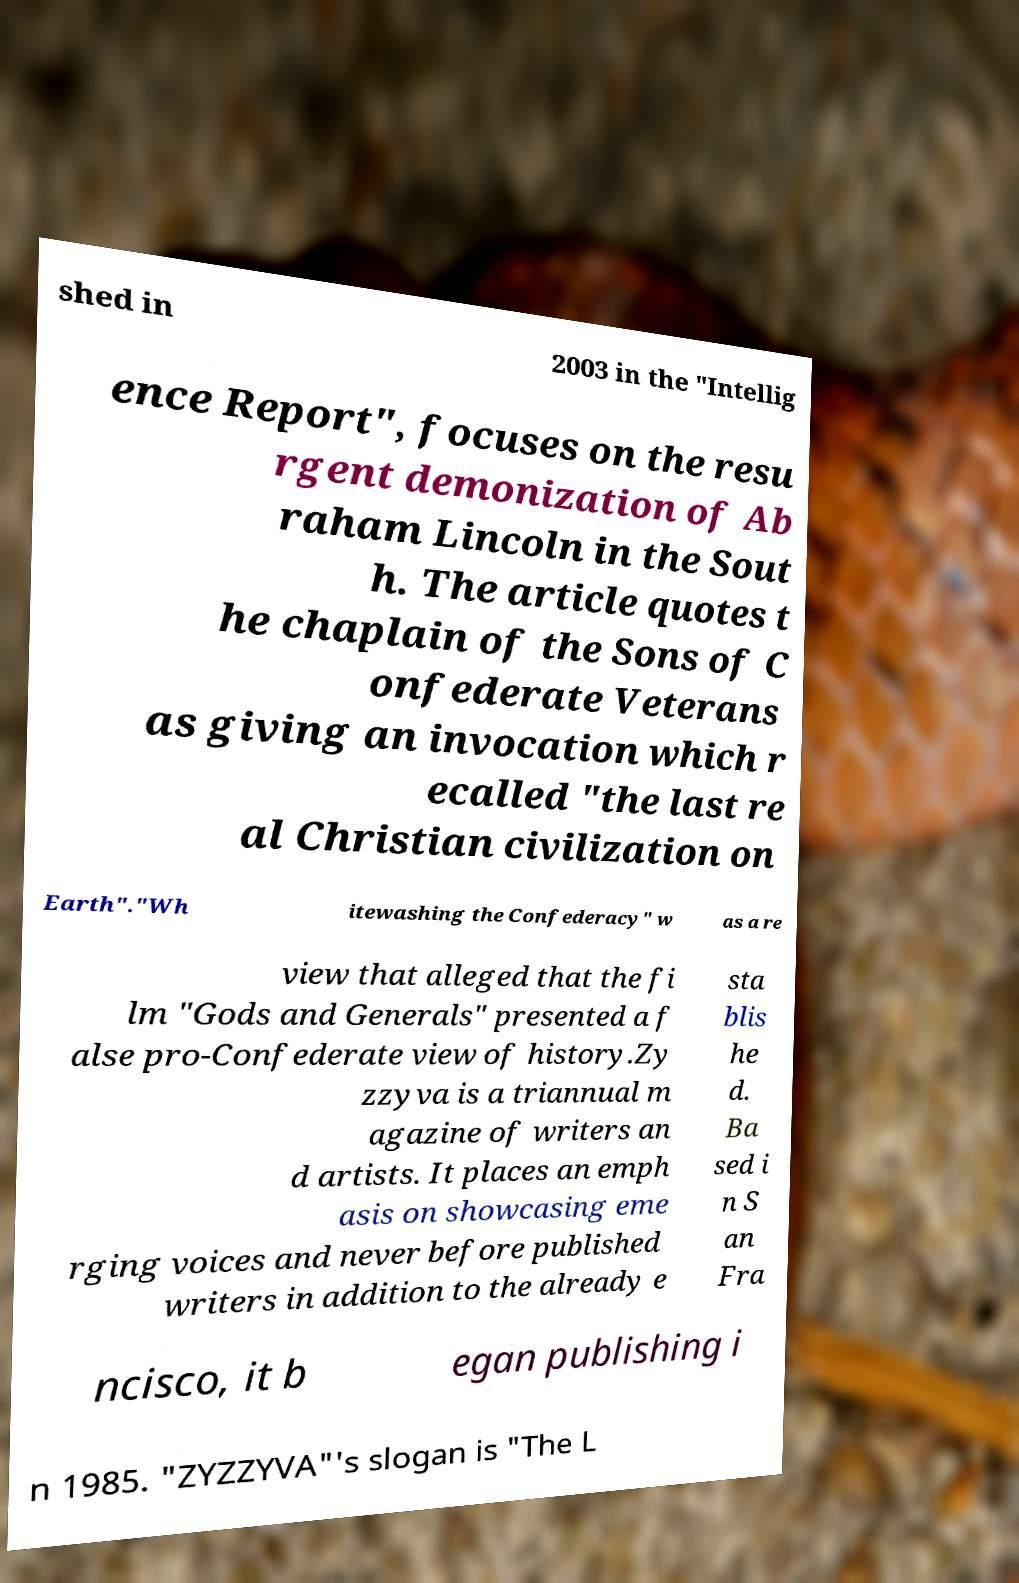What messages or text are displayed in this image? I need them in a readable, typed format. shed in 2003 in the "Intellig ence Report", focuses on the resu rgent demonization of Ab raham Lincoln in the Sout h. The article quotes t he chaplain of the Sons of C onfederate Veterans as giving an invocation which r ecalled "the last re al Christian civilization on Earth"."Wh itewashing the Confederacy" w as a re view that alleged that the fi lm "Gods and Generals" presented a f alse pro-Confederate view of history.Zy zzyva is a triannual m agazine of writers an d artists. It places an emph asis on showcasing eme rging voices and never before published writers in addition to the already e sta blis he d. Ba sed i n S an Fra ncisco, it b egan publishing i n 1985. "ZYZZYVA"'s slogan is "The L 